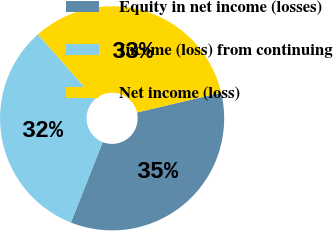Convert chart. <chart><loc_0><loc_0><loc_500><loc_500><pie_chart><fcel>Equity in net income (losses)<fcel>Income (loss) from continuing<fcel>Net income (loss)<nl><fcel>34.68%<fcel>32.49%<fcel>32.83%<nl></chart> 